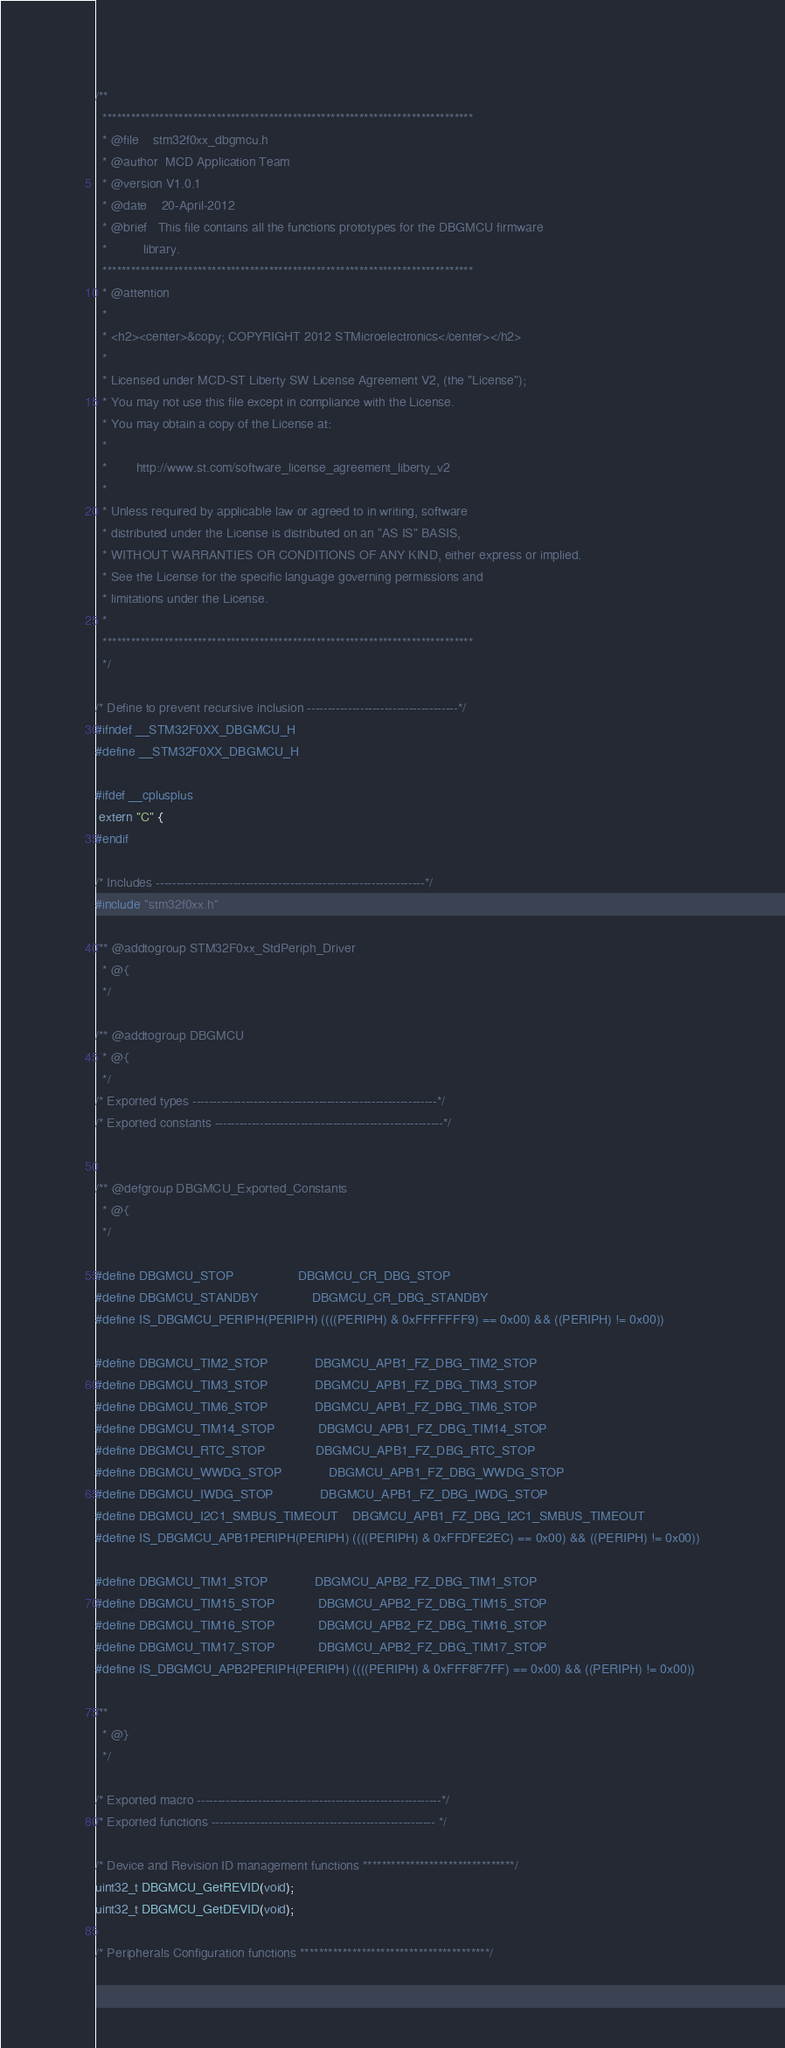Convert code to text. <code><loc_0><loc_0><loc_500><loc_500><_C_>/**
  ******************************************************************************
  * @file    stm32f0xx_dbgmcu.h
  * @author  MCD Application Team
  * @version V1.0.1
  * @date    20-April-2012
  * @brief   This file contains all the functions prototypes for the DBGMCU firmware 
  *          library.
  ******************************************************************************
  * @attention
  *
  * <h2><center>&copy; COPYRIGHT 2012 STMicroelectronics</center></h2>
  *
  * Licensed under MCD-ST Liberty SW License Agreement V2, (the "License");
  * You may not use this file except in compliance with the License.
  * You may obtain a copy of the License at:
  *
  *        http://www.st.com/software_license_agreement_liberty_v2
  *
  * Unless required by applicable law or agreed to in writing, software 
  * distributed under the License is distributed on an "AS IS" BASIS, 
  * WITHOUT WARRANTIES OR CONDITIONS OF ANY KIND, either express or implied.
  * See the License for the specific language governing permissions and
  * limitations under the License.
  *
  ******************************************************************************
  */

/* Define to prevent recursive inclusion -------------------------------------*/
#ifndef __STM32F0XX_DBGMCU_H
#define __STM32F0XX_DBGMCU_H

#ifdef __cplusplus
 extern "C" {
#endif

/* Includes ------------------------------------------------------------------*/
#include "stm32f0xx.h"

/** @addtogroup STM32F0xx_StdPeriph_Driver
  * @{
  */

/** @addtogroup DBGMCU
  * @{
  */ 
/* Exported types ------------------------------------------------------------*/ 
/* Exported constants --------------------------------------------------------*/


/** @defgroup DBGMCU_Exported_Constants
  * @{
  */

#define DBGMCU_STOP                  DBGMCU_CR_DBG_STOP
#define DBGMCU_STANDBY               DBGMCU_CR_DBG_STANDBY
#define IS_DBGMCU_PERIPH(PERIPH) ((((PERIPH) & 0xFFFFFFF9) == 0x00) && ((PERIPH) != 0x00))

#define DBGMCU_TIM2_STOP             DBGMCU_APB1_FZ_DBG_TIM2_STOP
#define DBGMCU_TIM3_STOP             DBGMCU_APB1_FZ_DBG_TIM3_STOP
#define DBGMCU_TIM6_STOP             DBGMCU_APB1_FZ_DBG_TIM6_STOP
#define DBGMCU_TIM14_STOP            DBGMCU_APB1_FZ_DBG_TIM14_STOP
#define DBGMCU_RTC_STOP              DBGMCU_APB1_FZ_DBG_RTC_STOP
#define DBGMCU_WWDG_STOP             DBGMCU_APB1_FZ_DBG_WWDG_STOP
#define DBGMCU_IWDG_STOP             DBGMCU_APB1_FZ_DBG_IWDG_STOP
#define DBGMCU_I2C1_SMBUS_TIMEOUT    DBGMCU_APB1_FZ_DBG_I2C1_SMBUS_TIMEOUT
#define IS_DBGMCU_APB1PERIPH(PERIPH) ((((PERIPH) & 0xFFDFE2EC) == 0x00) && ((PERIPH) != 0x00))

#define DBGMCU_TIM1_STOP             DBGMCU_APB2_FZ_DBG_TIM1_STOP
#define DBGMCU_TIM15_STOP            DBGMCU_APB2_FZ_DBG_TIM15_STOP
#define DBGMCU_TIM16_STOP            DBGMCU_APB2_FZ_DBG_TIM16_STOP
#define DBGMCU_TIM17_STOP            DBGMCU_APB2_FZ_DBG_TIM17_STOP
#define IS_DBGMCU_APB2PERIPH(PERIPH) ((((PERIPH) & 0xFFF8F7FF) == 0x00) && ((PERIPH) != 0x00))

/**
  * @}
  */ 

/* Exported macro ------------------------------------------------------------*/
/* Exported functions ------------------------------------------------------- */ 

/* Device and Revision ID management functions ********************************/ 
uint32_t DBGMCU_GetREVID(void);
uint32_t DBGMCU_GetDEVID(void);

/* Peripherals Configuration functions ****************************************/ </code> 